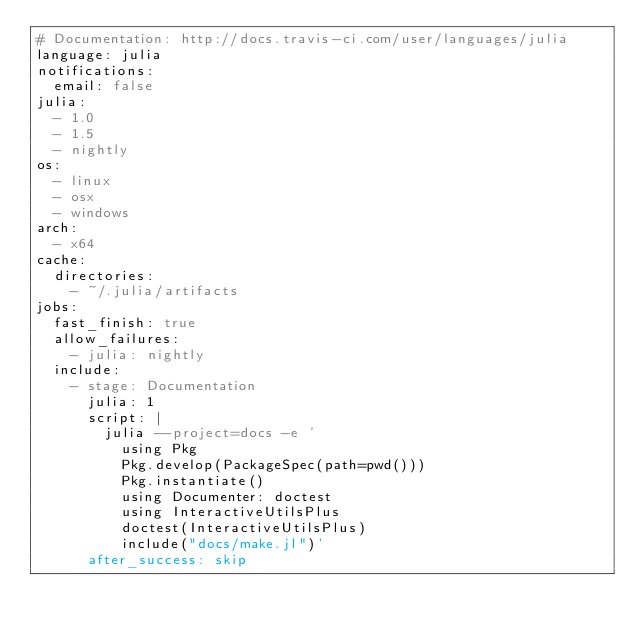Convert code to text. <code><loc_0><loc_0><loc_500><loc_500><_YAML_># Documentation: http://docs.travis-ci.com/user/languages/julia
language: julia
notifications:
  email: false
julia:
  - 1.0
  - 1.5
  - nightly
os:
  - linux
  - osx
  - windows
arch:
  - x64
cache:
  directories:
    - ~/.julia/artifacts
jobs:
  fast_finish: true
  allow_failures:
    - julia: nightly
  include:
    - stage: Documentation
      julia: 1
      script: |
        julia --project=docs -e '
          using Pkg
          Pkg.develop(PackageSpec(path=pwd()))
          Pkg.instantiate()
          using Documenter: doctest
          using InteractiveUtilsPlus
          doctest(InteractiveUtilsPlus)
          include("docs/make.jl")'
      after_success: skip
</code> 